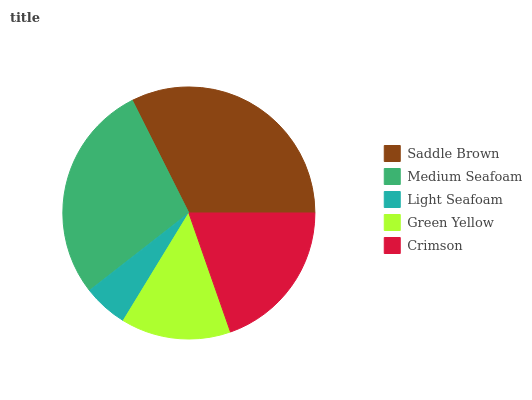Is Light Seafoam the minimum?
Answer yes or no. Yes. Is Saddle Brown the maximum?
Answer yes or no. Yes. Is Medium Seafoam the minimum?
Answer yes or no. No. Is Medium Seafoam the maximum?
Answer yes or no. No. Is Saddle Brown greater than Medium Seafoam?
Answer yes or no. Yes. Is Medium Seafoam less than Saddle Brown?
Answer yes or no. Yes. Is Medium Seafoam greater than Saddle Brown?
Answer yes or no. No. Is Saddle Brown less than Medium Seafoam?
Answer yes or no. No. Is Crimson the high median?
Answer yes or no. Yes. Is Crimson the low median?
Answer yes or no. Yes. Is Medium Seafoam the high median?
Answer yes or no. No. Is Green Yellow the low median?
Answer yes or no. No. 